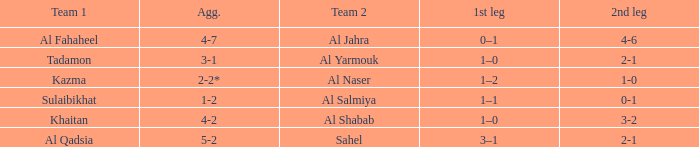What is the 1st leg of the match with a 2nd leg of 3-2? 1–0. 